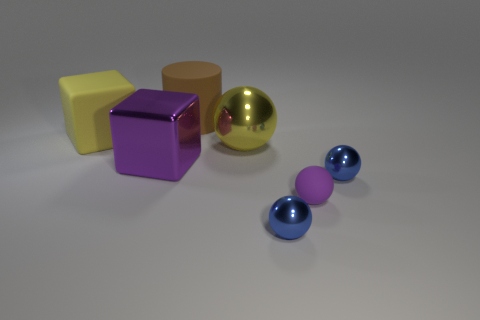Do the large ball and the matte block have the same color?
Your answer should be compact. Yes. Is there any other thing that has the same shape as the brown thing?
Provide a succinct answer. No. There is a cylinder that is the same size as the yellow sphere; what material is it?
Offer a very short reply. Rubber. What number of big purple objects have the same material as the purple sphere?
Your answer should be compact. 0. Is the size of the yellow rubber object that is in front of the big cylinder the same as the rubber object that is in front of the purple shiny thing?
Your response must be concise. No. The tiny thing behind the small purple object is what color?
Make the answer very short. Blue. What material is the thing that is the same color as the large sphere?
Keep it short and to the point. Rubber. What number of things have the same color as the rubber block?
Keep it short and to the point. 1. There is a rubber ball; does it have the same size as the shiny ball in front of the matte ball?
Your answer should be compact. Yes. There is a yellow object on the left side of the cube to the right of the big cube that is left of the big purple cube; what size is it?
Keep it short and to the point. Large. 